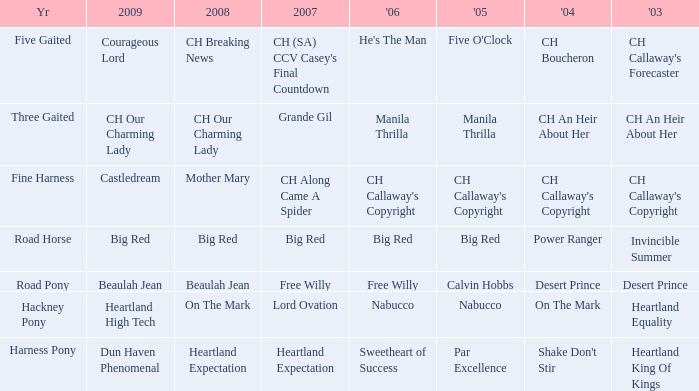What is the 2007 for the 2003 desert prince? Free Willy. 